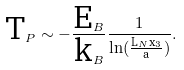<formula> <loc_0><loc_0><loc_500><loc_500>\text {T} _ { P } \sim - \frac { \text {E} _ { B } } { \text {k} _ { B } } \frac { 1 } { \ln ( \frac { \text {L} _ { N } \text {x} _ { 3 } } { \text {a} } ) } .</formula> 